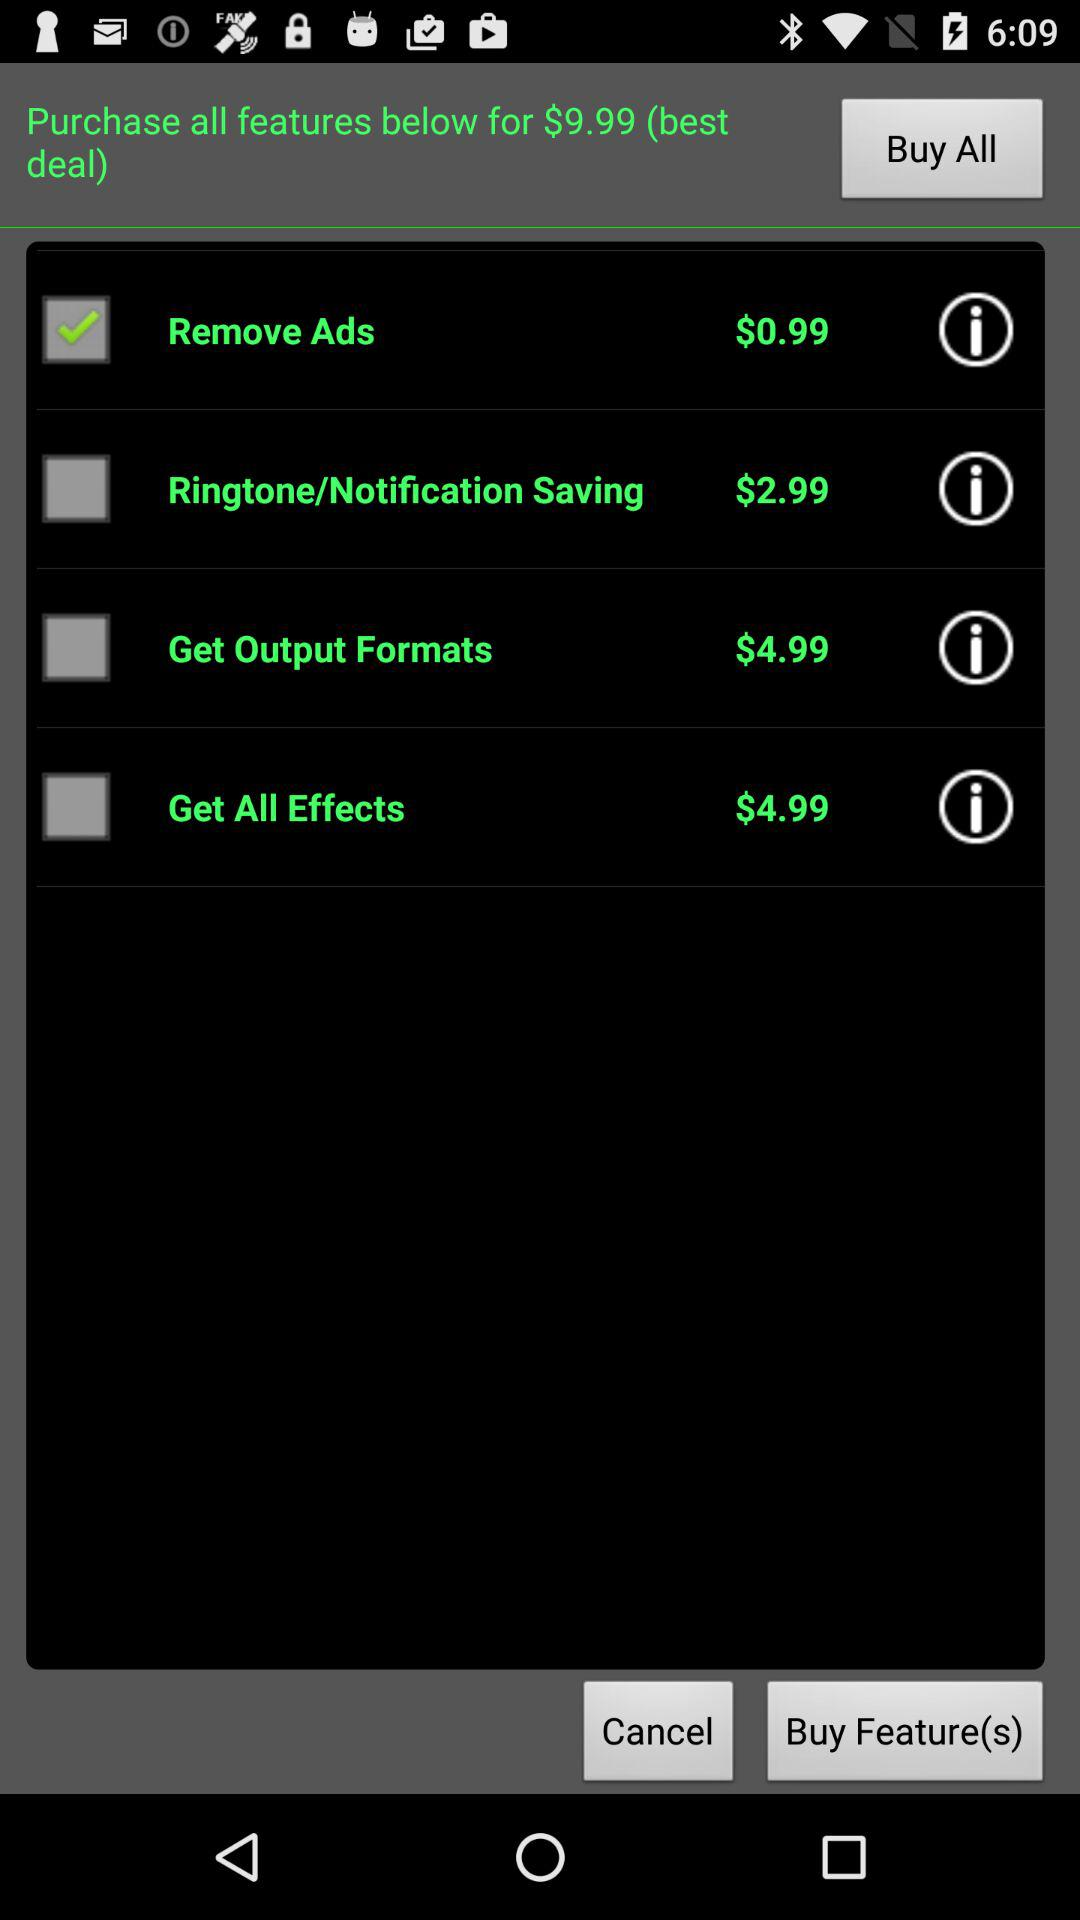What is the purchase price of "Ringtone Saving"? The purchase price of "Ringtone Saving" is $2.99. 